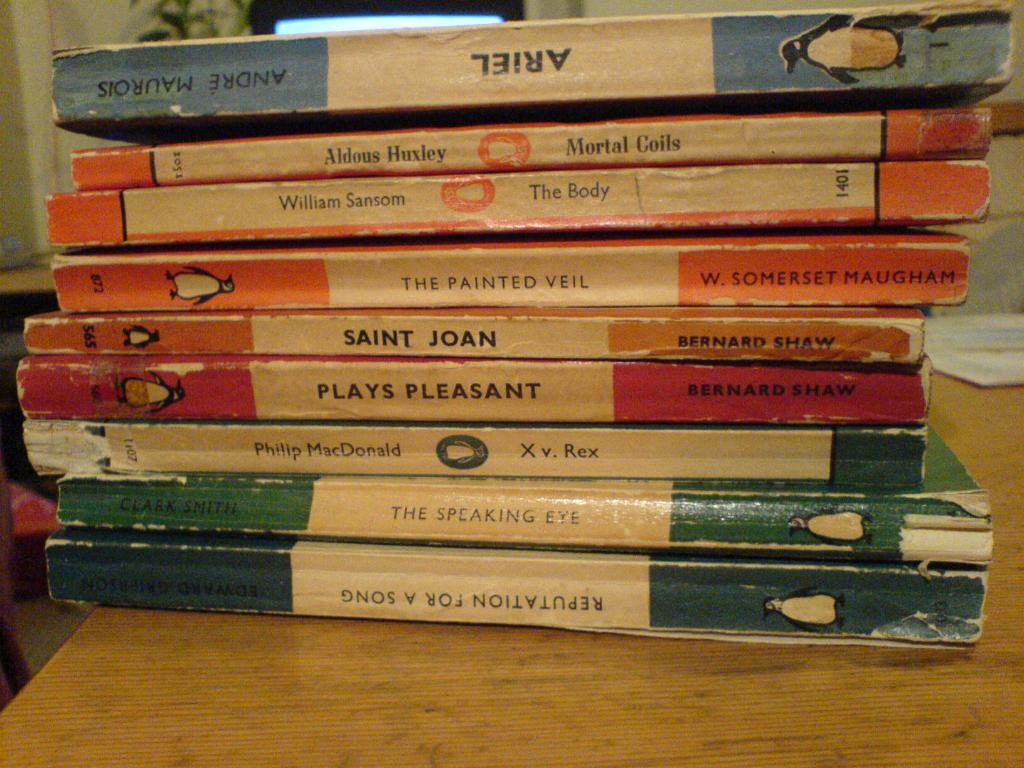What objects are on the table in the image? There are books on the table in the image. What type of vegetation can be seen in the background? Green leaves are visible in the background. What is located behind the table in the image? There is a wall in the background. Where is the throne located in the image? There is no throne present in the image. What type of ray can be seen flying in the background? There are no rays visible in the image; only green leaves and a wall are present in the background. 